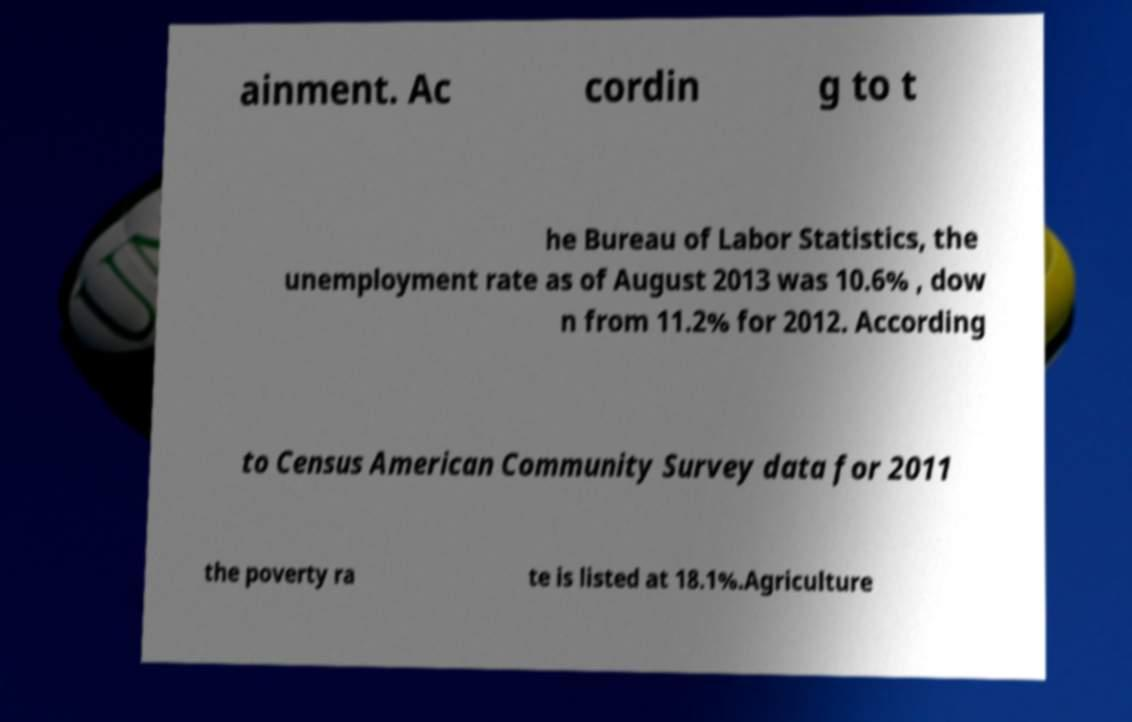What messages or text are displayed in this image? I need them in a readable, typed format. ainment. Ac cordin g to t he Bureau of Labor Statistics, the unemployment rate as of August 2013 was 10.6% , dow n from 11.2% for 2012. According to Census American Community Survey data for 2011 the poverty ra te is listed at 18.1%.Agriculture 